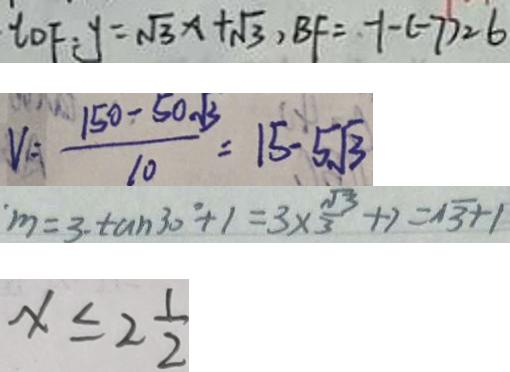<formula> <loc_0><loc_0><loc_500><loc_500>t _ { D F } : y = \sqrt { 3 } x + \sqrt { 3 } , B F = - 1 - ( - 7 ) = 6 
 V = \frac { 1 5 0 - 5 0 \sqrt { 3 } } { 1 0 } = 1 5 - 5 \sqrt { 3 } 
 m = 3 \cdot \tan 3 0 ^ { \circ } + 1 = 3 \times \frac { \sqrt { 3 } } { 3 } + 7 = \sqrt { 3 } + 1 
 x \leq 2 \frac { 1 } { 2 }</formula> 